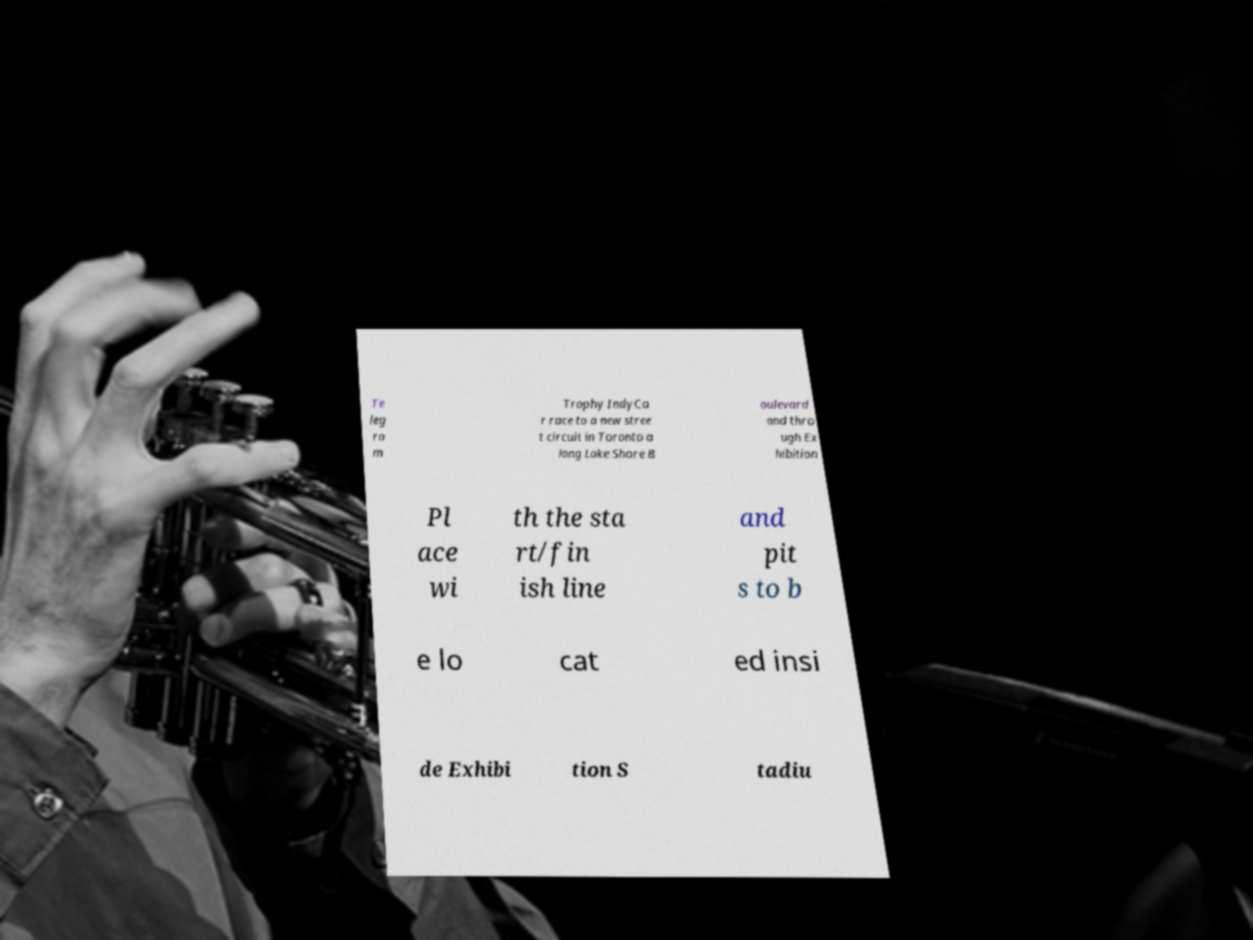Could you assist in decoding the text presented in this image and type it out clearly? Te leg ra m Trophy IndyCa r race to a new stree t circuit in Toronto a long Lake Shore B oulevard and thro ugh Ex hibition Pl ace wi th the sta rt/fin ish line and pit s to b e lo cat ed insi de Exhibi tion S tadiu 